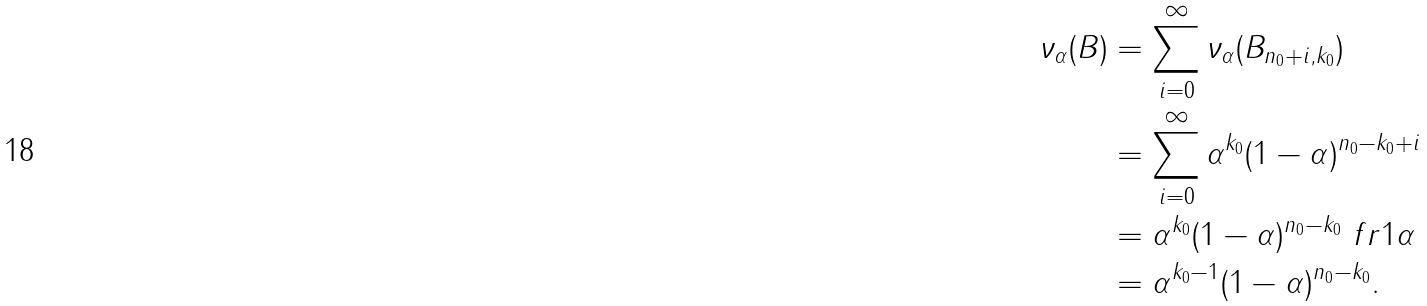Convert formula to latex. <formula><loc_0><loc_0><loc_500><loc_500>\nu _ { \alpha } ( B ) & = \sum _ { i = 0 } ^ { \infty } \nu _ { \alpha } ( B _ { n _ { 0 } + i , k _ { 0 } } ) \\ & = \sum _ { i = 0 } ^ { \infty } \alpha ^ { k _ { 0 } } ( 1 - \alpha ) ^ { n _ { 0 } - k _ { 0 } + i } \\ & = \alpha ^ { k _ { 0 } } ( 1 - \alpha ) ^ { n _ { 0 } - k _ { 0 } } \ f r { 1 } { \alpha } \\ & = \alpha ^ { k _ { 0 } - 1 } ( 1 - \alpha ) ^ { n _ { 0 } - k _ { 0 } } .</formula> 